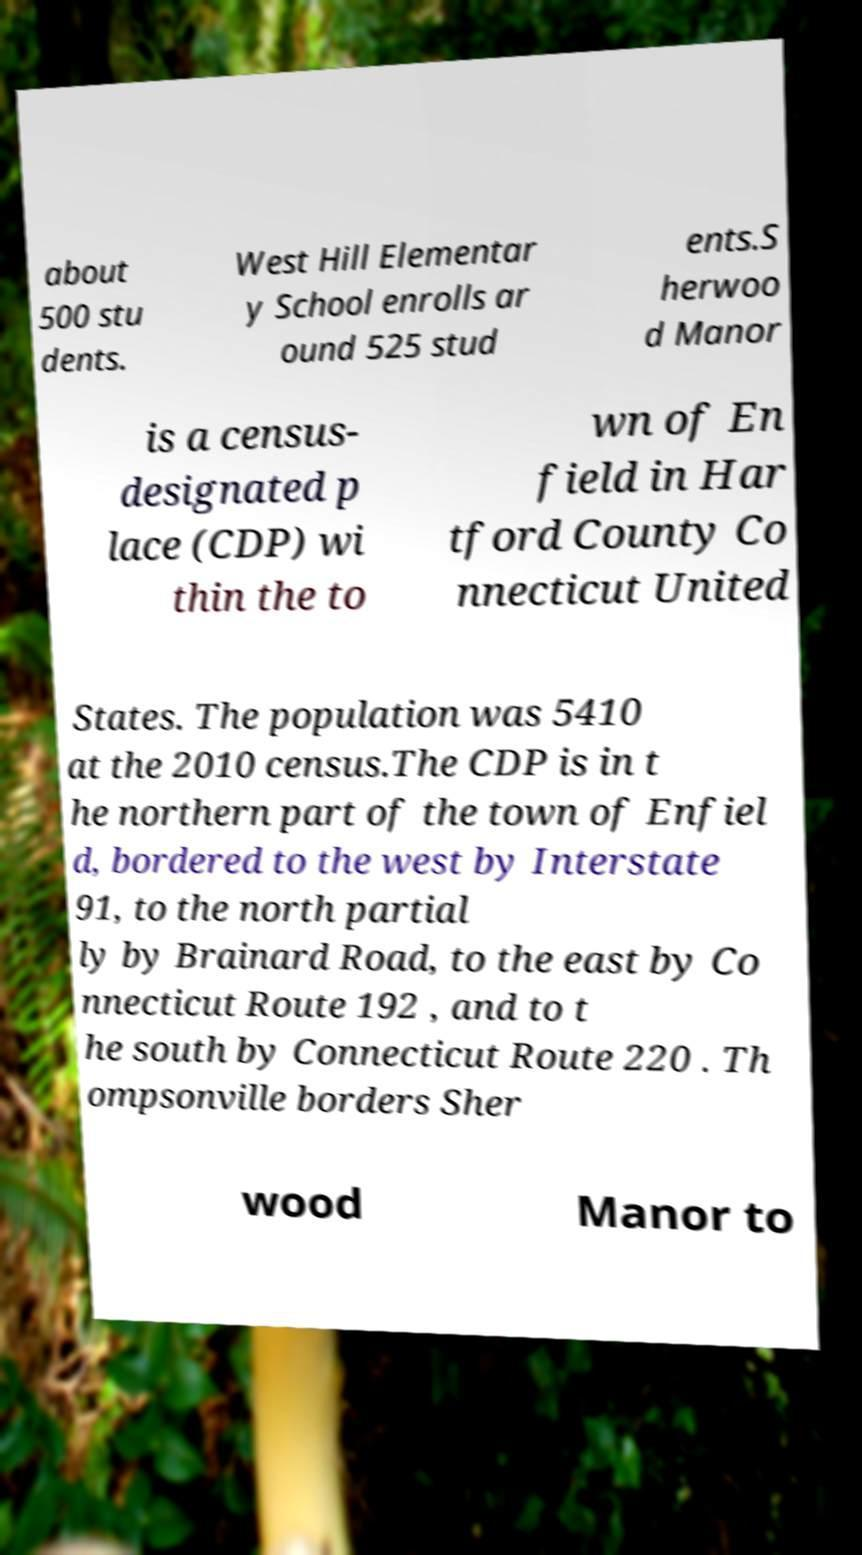I need the written content from this picture converted into text. Can you do that? about 500 stu dents. West Hill Elementar y School enrolls ar ound 525 stud ents.S herwoo d Manor is a census- designated p lace (CDP) wi thin the to wn of En field in Har tford County Co nnecticut United States. The population was 5410 at the 2010 census.The CDP is in t he northern part of the town of Enfiel d, bordered to the west by Interstate 91, to the north partial ly by Brainard Road, to the east by Co nnecticut Route 192 , and to t he south by Connecticut Route 220 . Th ompsonville borders Sher wood Manor to 